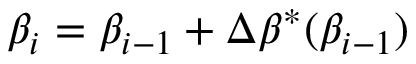<formula> <loc_0><loc_0><loc_500><loc_500>\beta _ { i } = \beta _ { i - 1 } + \Delta \beta ^ { * } ( \beta _ { i - 1 } )</formula> 